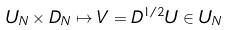Convert formula to latex. <formula><loc_0><loc_0><loc_500><loc_500>U _ { N } \times D _ { N } \mapsto V = D ^ { 1 / 2 } U \in U _ { N }</formula> 